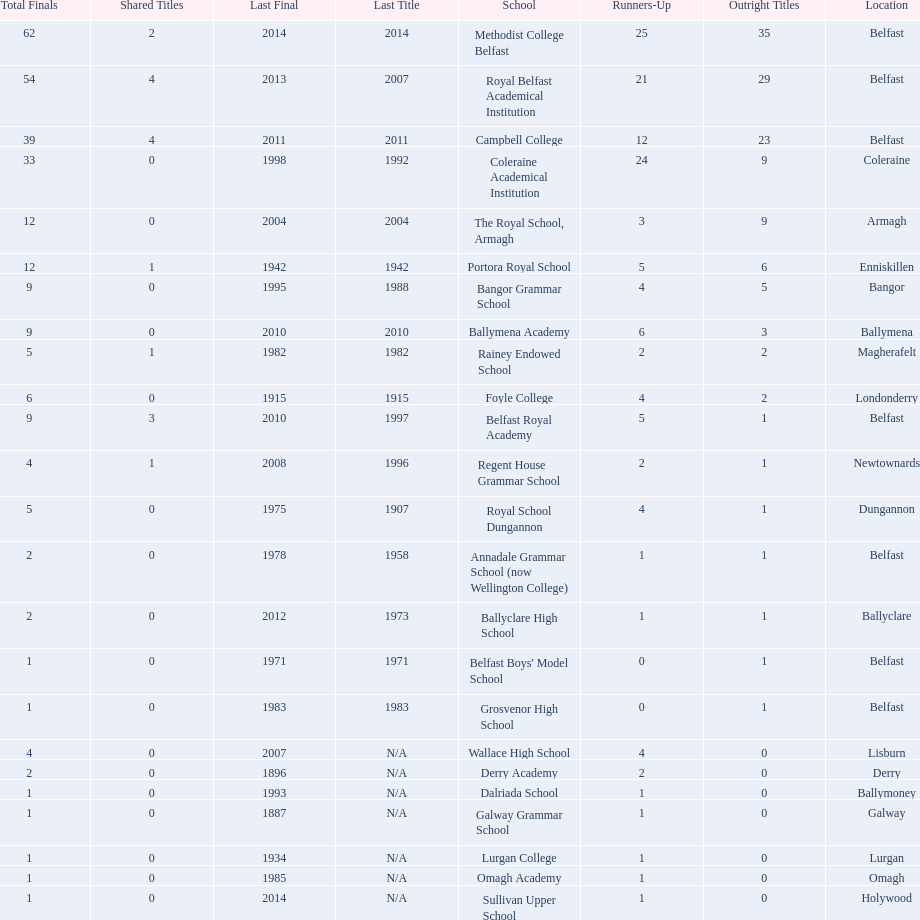How many outright titles does coleraine academical institution have? 9. What other school has this amount of outright titles The Royal School, Armagh. 